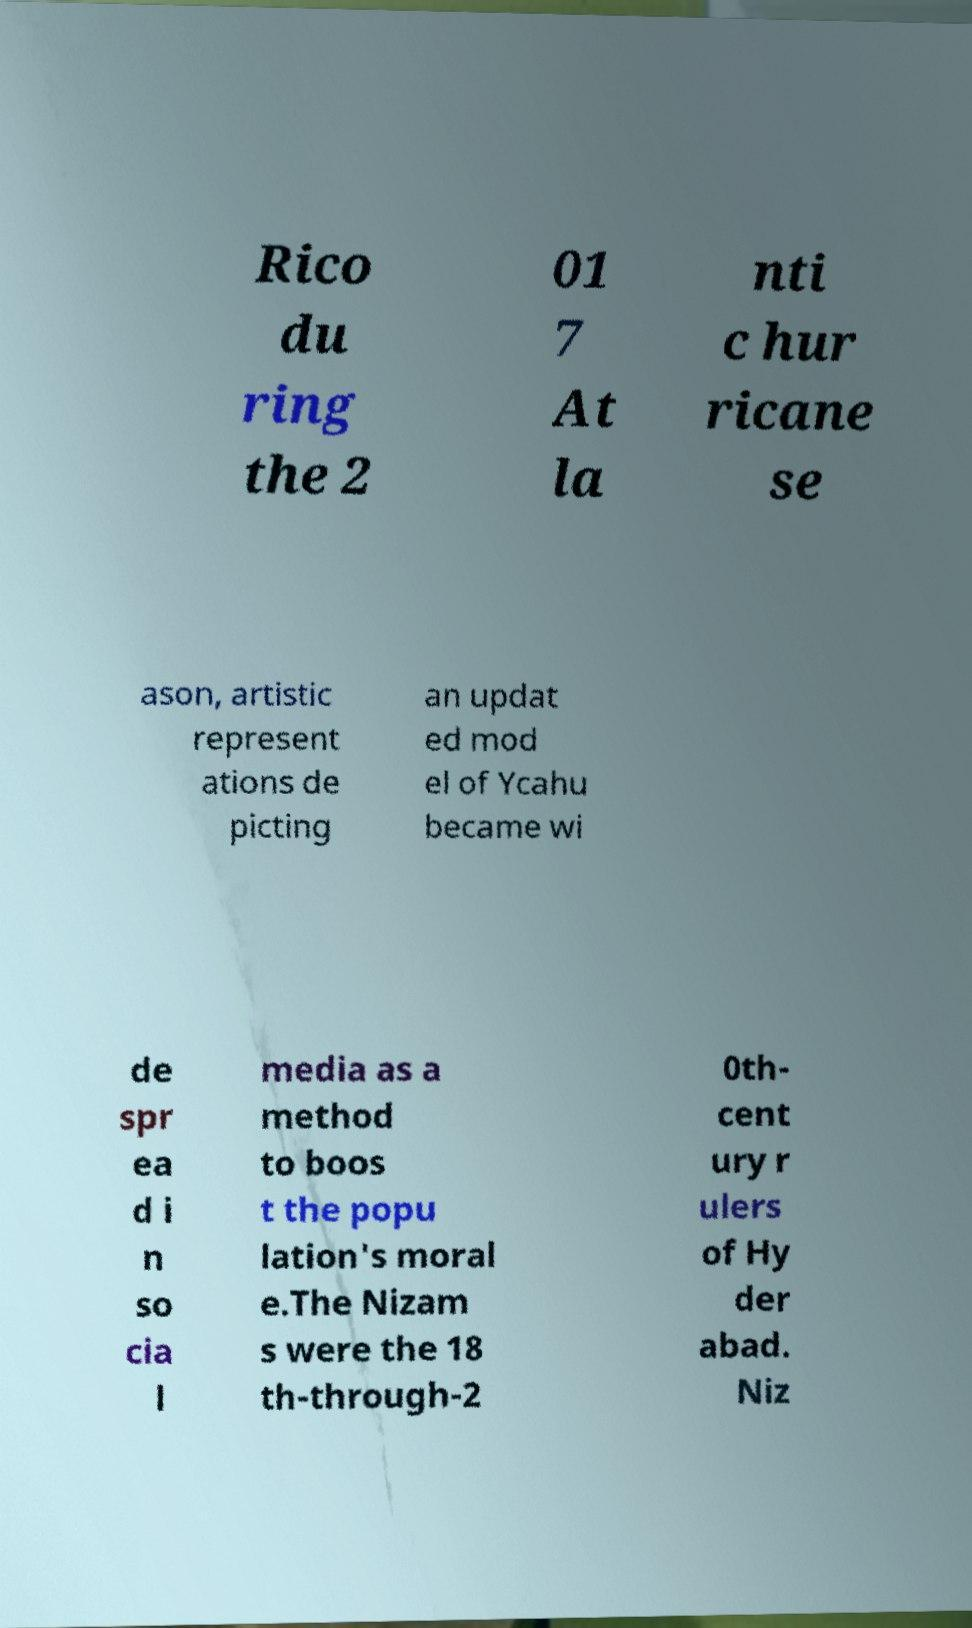Please read and relay the text visible in this image. What does it say? Rico du ring the 2 01 7 At la nti c hur ricane se ason, artistic represent ations de picting an updat ed mod el of Ycahu became wi de spr ea d i n so cia l media as a method to boos t the popu lation's moral e.The Nizam s were the 18 th-through-2 0th- cent ury r ulers of Hy der abad. Niz 